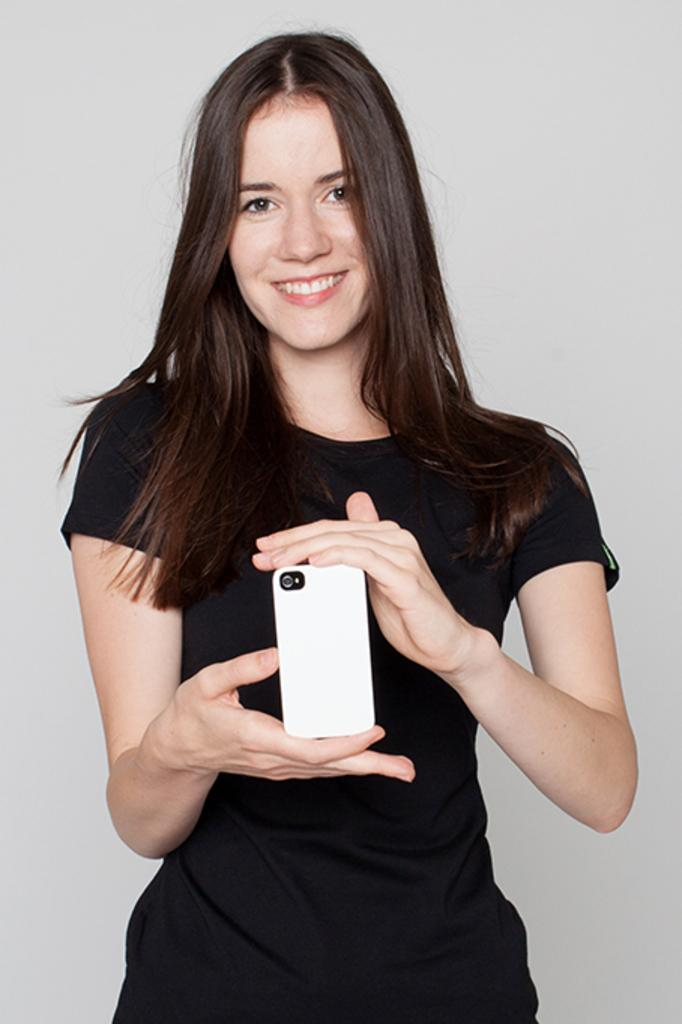Who is the main subject in the image? There is a woman in the image. What is the woman doing in the image? The woman is standing and smiling. What is the woman holding in her hands? The woman is holding a mobile in her hands. What type of snakes can be seen slithering around the woman's feet in the image? There are no snakes present in the image; the woman is holding a mobile in her hands. What kind of apparatus is the woman using to communicate with others in the image? The woman is holding a mobile in her hands, which is a communication device, but it is not an apparatus. 